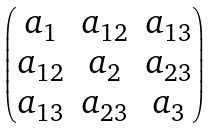Convert formula to latex. <formula><loc_0><loc_0><loc_500><loc_500>\begin{pmatrix} a _ { 1 } & a _ { 1 2 } & a _ { 1 3 } \\ a _ { 1 2 } & a _ { 2 } & a _ { 2 3 } \\ a _ { 1 3 } & a _ { 2 3 } & a _ { 3 } \end{pmatrix}</formula> 